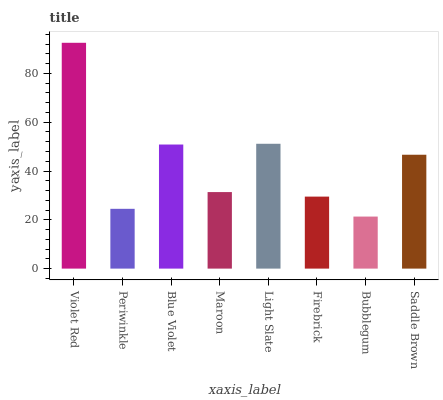Is Bubblegum the minimum?
Answer yes or no. Yes. Is Violet Red the maximum?
Answer yes or no. Yes. Is Periwinkle the minimum?
Answer yes or no. No. Is Periwinkle the maximum?
Answer yes or no. No. Is Violet Red greater than Periwinkle?
Answer yes or no. Yes. Is Periwinkle less than Violet Red?
Answer yes or no. Yes. Is Periwinkle greater than Violet Red?
Answer yes or no. No. Is Violet Red less than Periwinkle?
Answer yes or no. No. Is Saddle Brown the high median?
Answer yes or no. Yes. Is Maroon the low median?
Answer yes or no. Yes. Is Blue Violet the high median?
Answer yes or no. No. Is Periwinkle the low median?
Answer yes or no. No. 